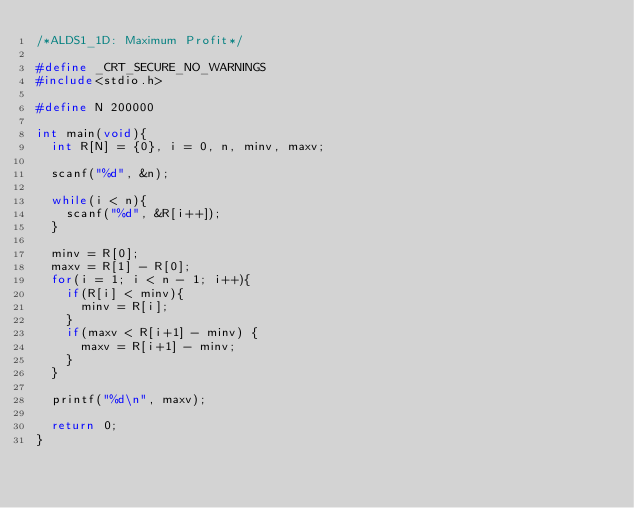Convert code to text. <code><loc_0><loc_0><loc_500><loc_500><_C_>/*ALDS1_1D: Maximum Profit*/

#define _CRT_SECURE_NO_WARNINGS
#include<stdio.h>

#define N 200000

int main(void){
	int R[N] = {0}, i = 0, n, minv, maxv;

	scanf("%d", &n);

	while(i < n){
		scanf("%d", &R[i++]);
	}

	minv = R[0];
	maxv = R[1] - R[0];
	for(i = 1; i < n - 1; i++){
		if(R[i] < minv){
			minv = R[i];
		}
		if(maxv < R[i+1] - minv) {
			maxv = R[i+1] - minv;
		}
	}

	printf("%d\n", maxv);

	return 0;
}
</code> 